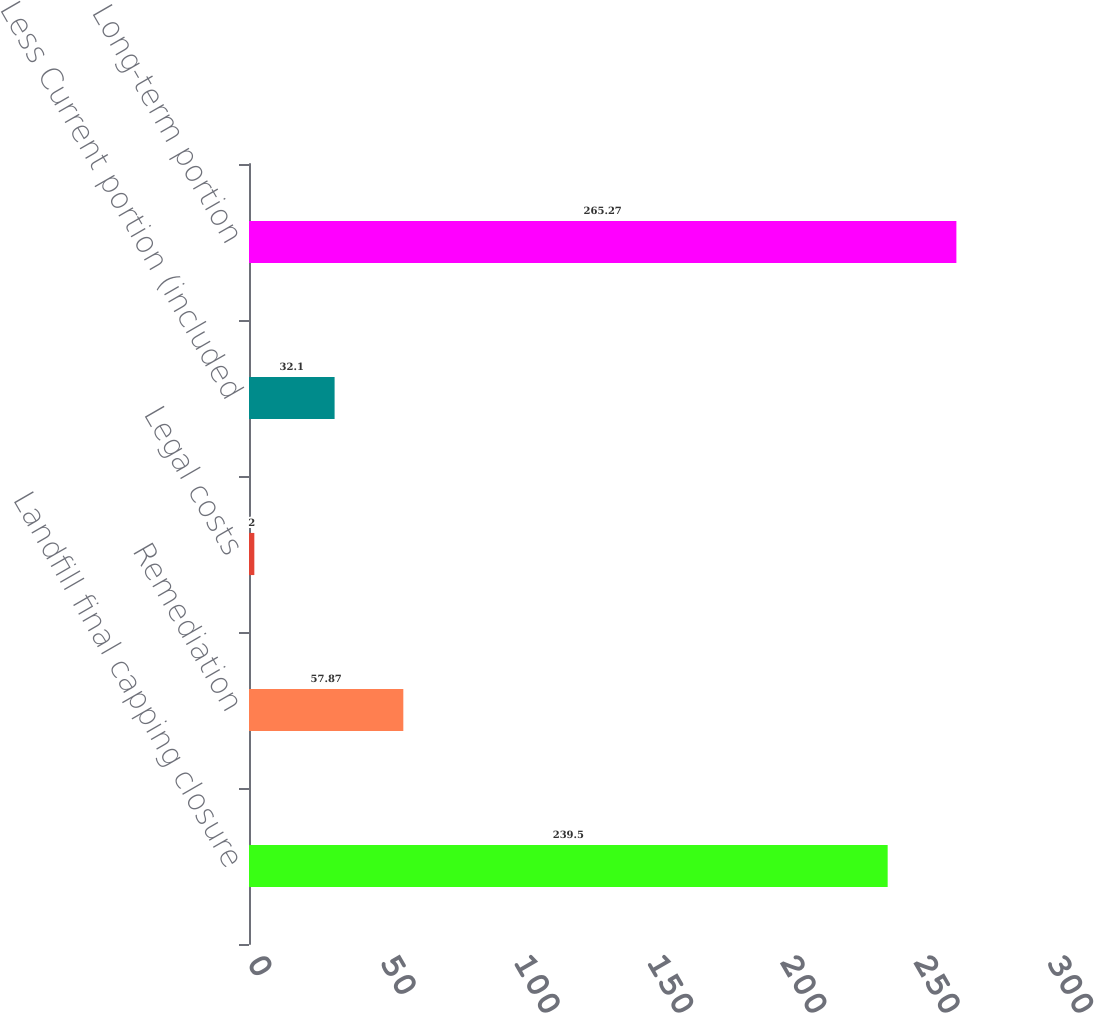Convert chart. <chart><loc_0><loc_0><loc_500><loc_500><bar_chart><fcel>Landfill final capping closure<fcel>Remediation<fcel>Legal costs<fcel>Less Current portion (included<fcel>Long-term portion<nl><fcel>239.5<fcel>57.87<fcel>2<fcel>32.1<fcel>265.27<nl></chart> 